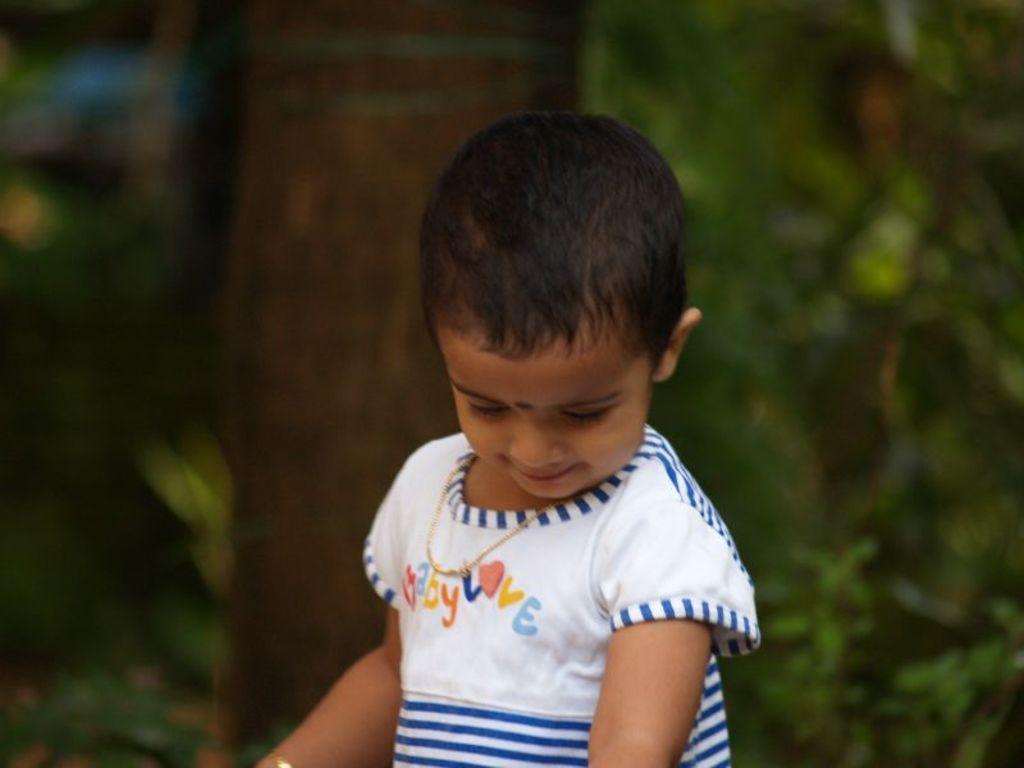In one or two sentences, can you explain what this image depicts? In the center of the picture there is a kid in white dress. The background is blurred. 